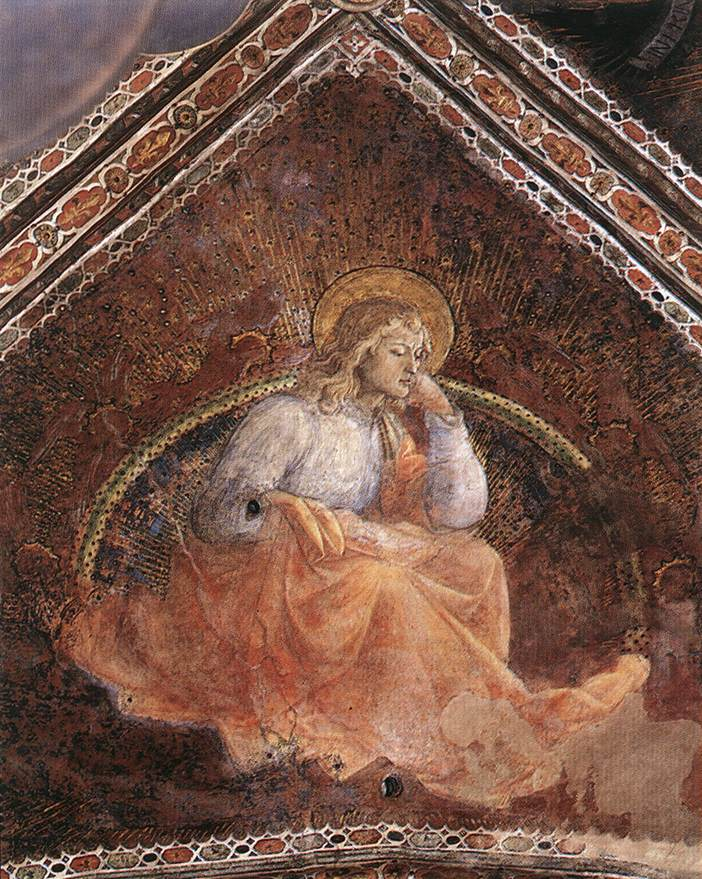Could you describe the artistic techniques used in this painting? The painting exemplifies Renaissance artistic techniques, notably its attention to realism and detail. The use of chiaroscuro — the contrast between light and dark — is evident in the way the angel’s bright figure is set against a darker background, creating a sense of depth and three-dimensionality. The careful application of color, with the delicate use of whites, golds, and reds, showcases the artist’s skill in blending and shading to achieve a lifelike representation. The intricate details in the background, including the golden accents and the patterned border, highlight the artist’s meticulous approach to design and ornamentation. The texture of the robes and the softness of the wings reflect an advanced understanding of fabric and form, while the overall composition balances symmetry and grandeur typical of Renaissance religious art. 